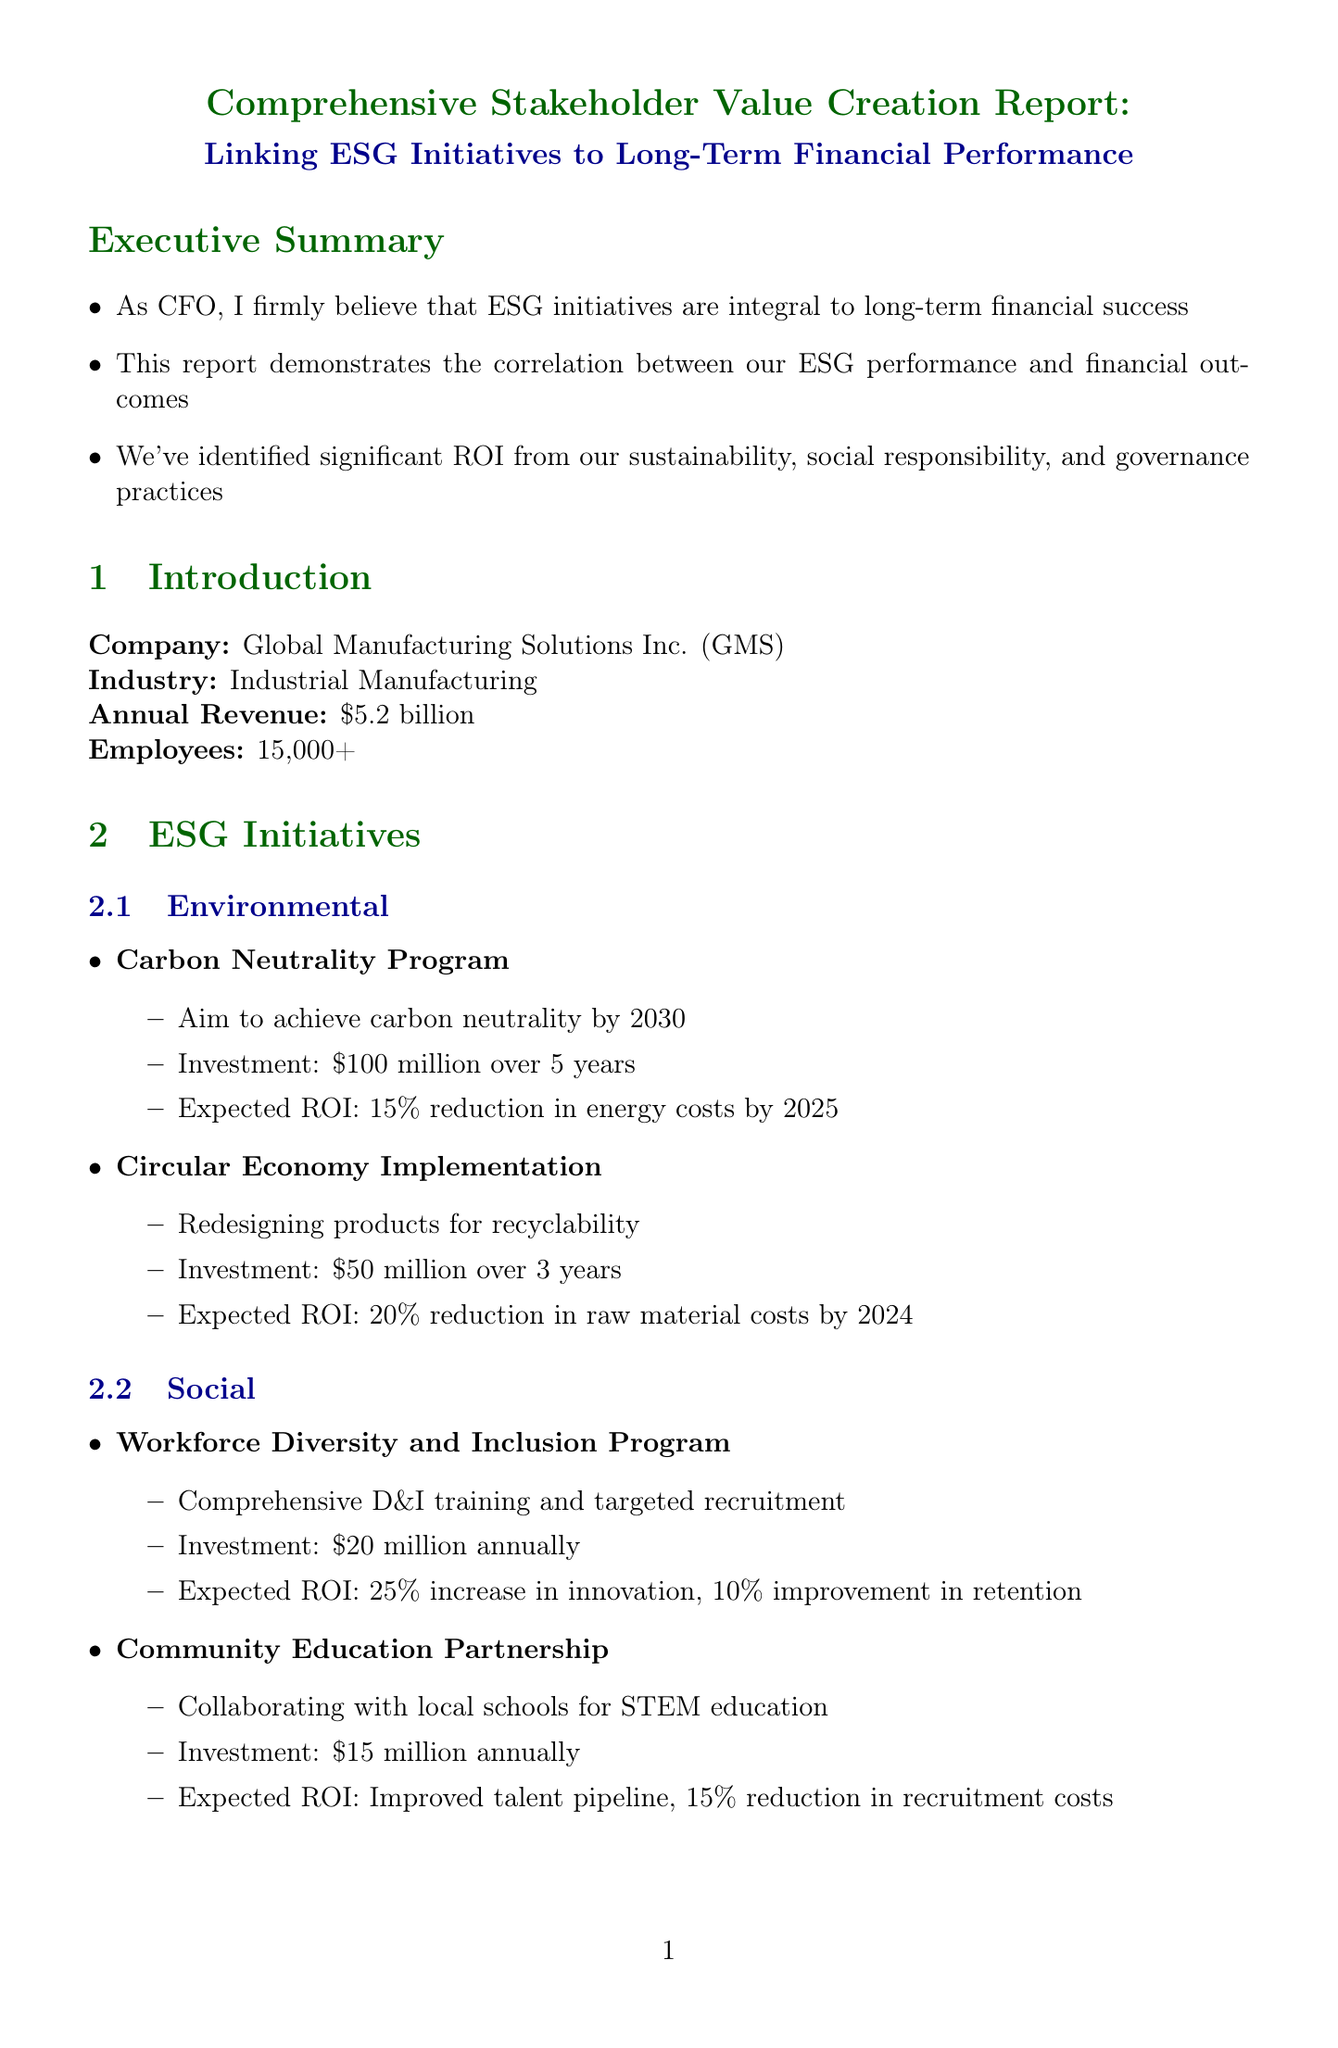what is the annual revenue of GMS? The annual revenue of Global Manufacturing Solutions Inc. (GMS) is stated in the introduction section.
Answer: $5.2 billion what is the investment amount for the Carbon Neutrality Program? The investment for the Carbon Neutrality Program is provided under the environmental initiatives.
Answer: $100 million over 5 years what is the expected ROI for the Circular Economy Implementation? The expected ROI for the Circular Economy Implementation is mentioned in the environmental section of ESG initiatives.
Answer: 20% reduction in raw material costs by 2024 how much is the projected CAGR for total shareholder return over the next 5 years? The projected CAGR for total shareholder return is included in the stakeholder value creation section regarding shareholders.
Answer: 12% CAGR what is the anticipated improvement in profit margin by 2030? The anticipated improvement in profit margin is detailed in the financial projections under the future outlook section.
Answer: Expected increase from 12% to 18% what is the investment for the Supplier Diversity Program? The investment amount for the Supplier Diversity Program is specified in the case study section.
Answer: $10 million in outreach and capacity building how many employees does GMS have? The number of employees at GMS is indicated in the introduction section.
Answer: 15,000+ what is the expected increase in employee engagement score? The increase in employee engagement score is presented in the stakeholder value creation section focused on employees.
Answer: Increased from 72% to 85% what is the financial benefit of the climate change risk mitigation strategy? The financial benefit of the climate change risk mitigation strategy is included in the risk mitigation section.
Answer: Avoided losses of $100 million from extreme weather events over 5 years 